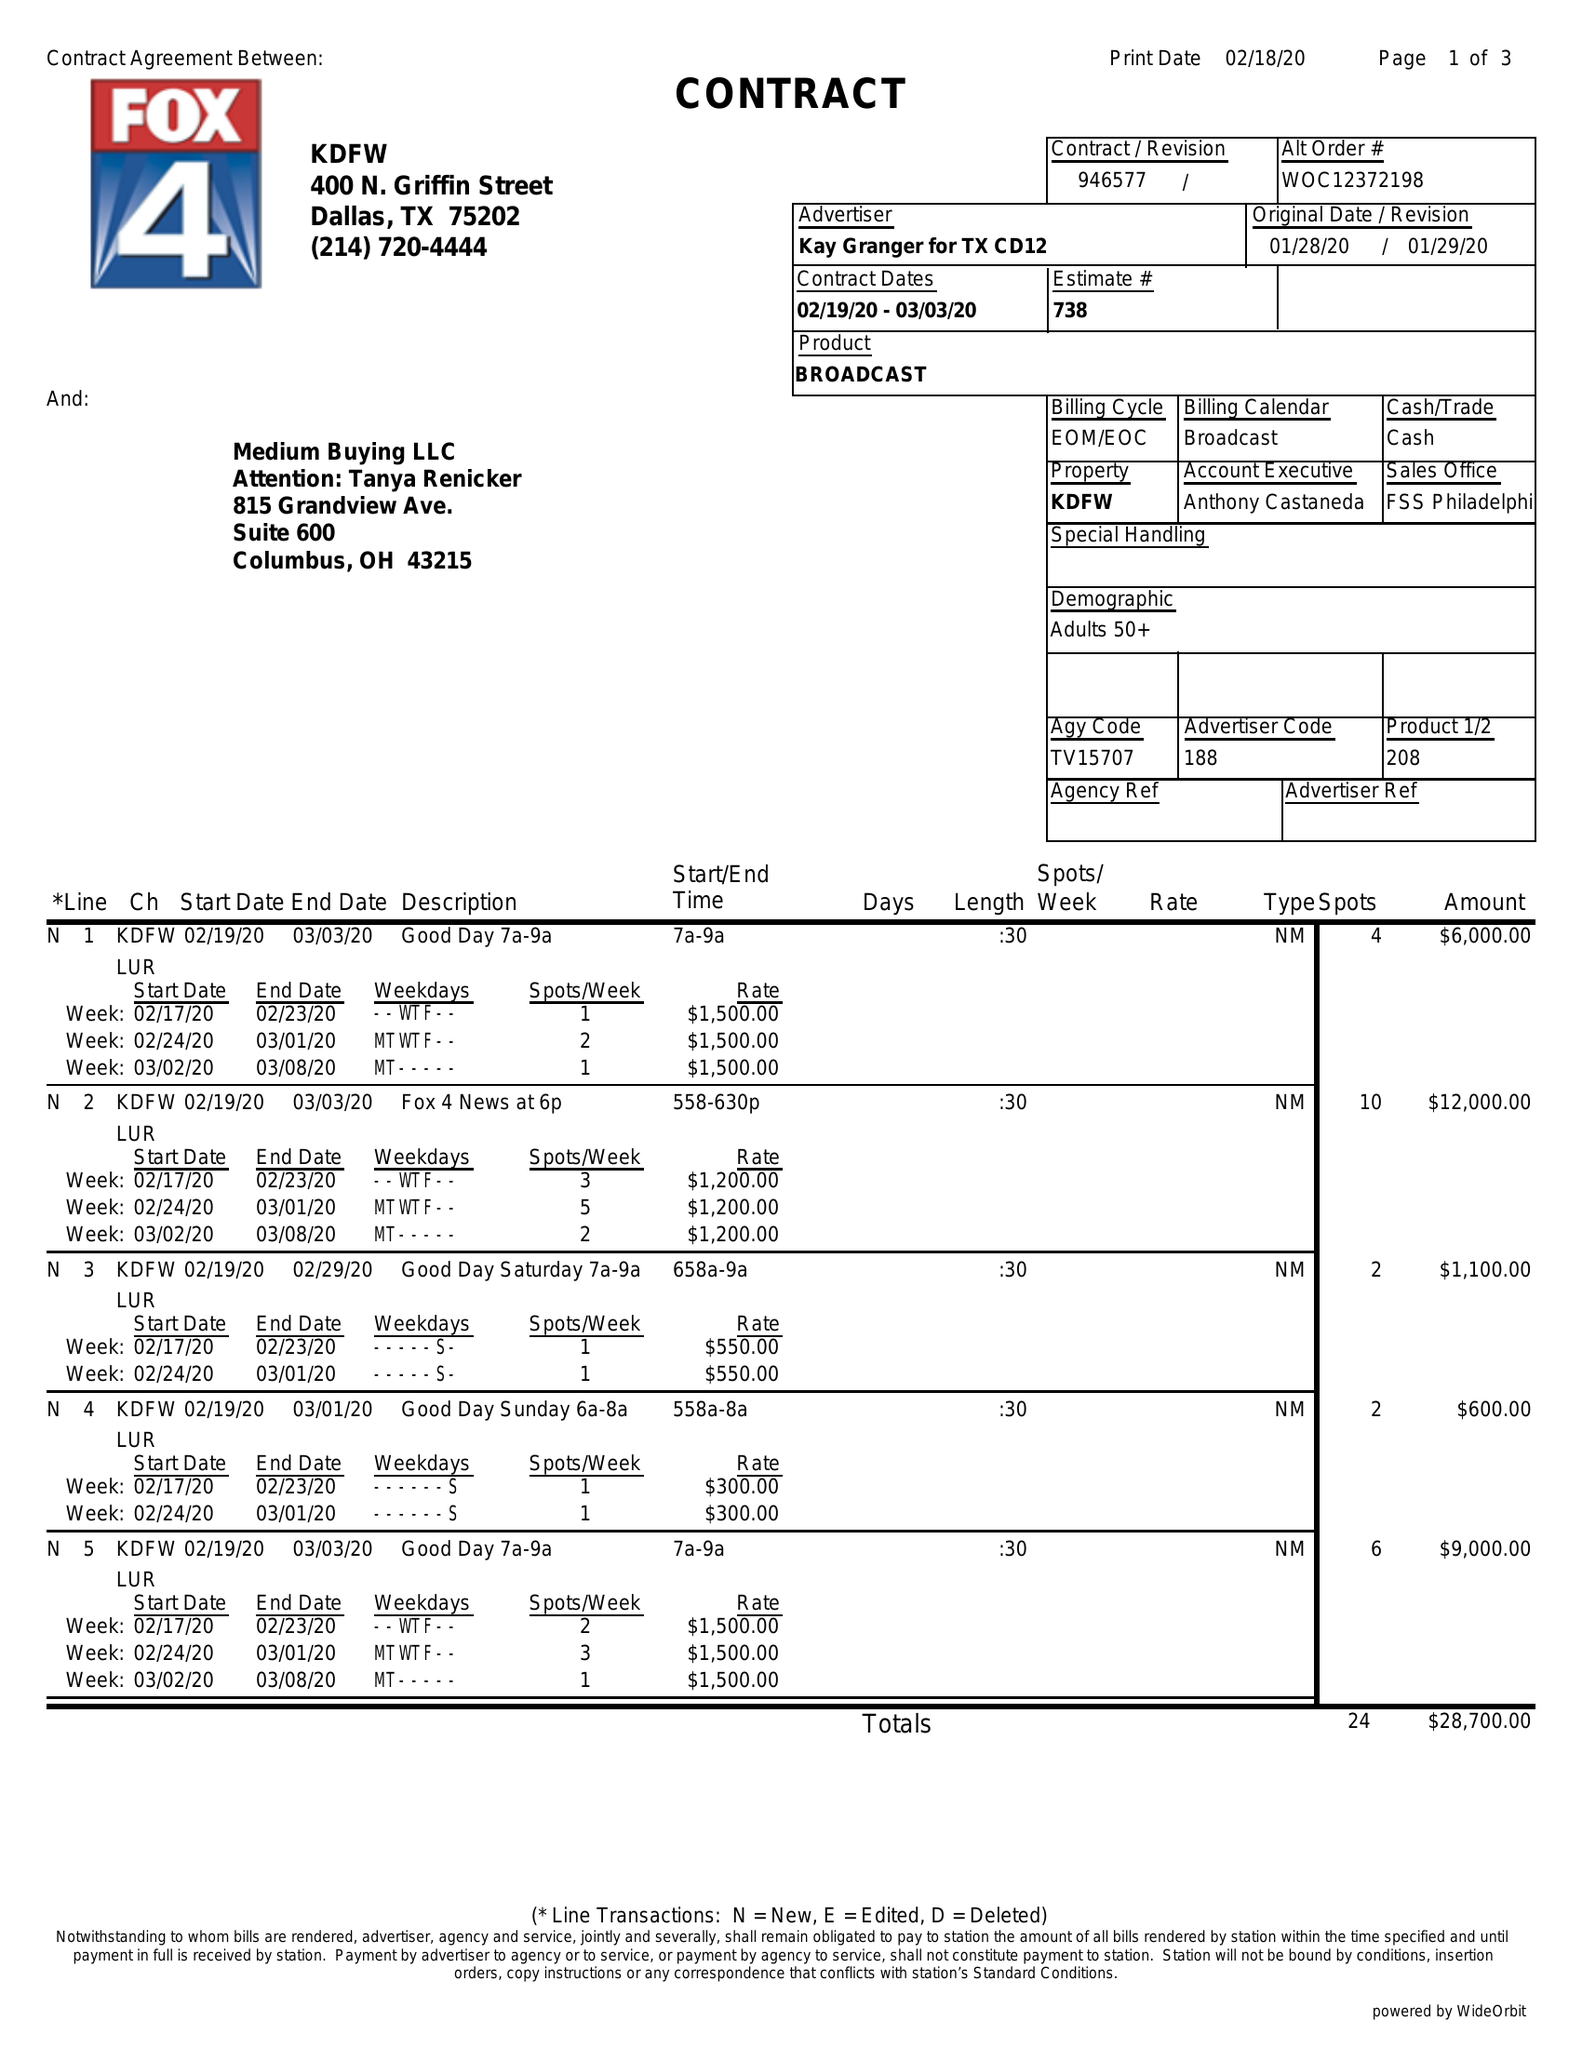What is the value for the gross_amount?
Answer the question using a single word or phrase. 28700.00 